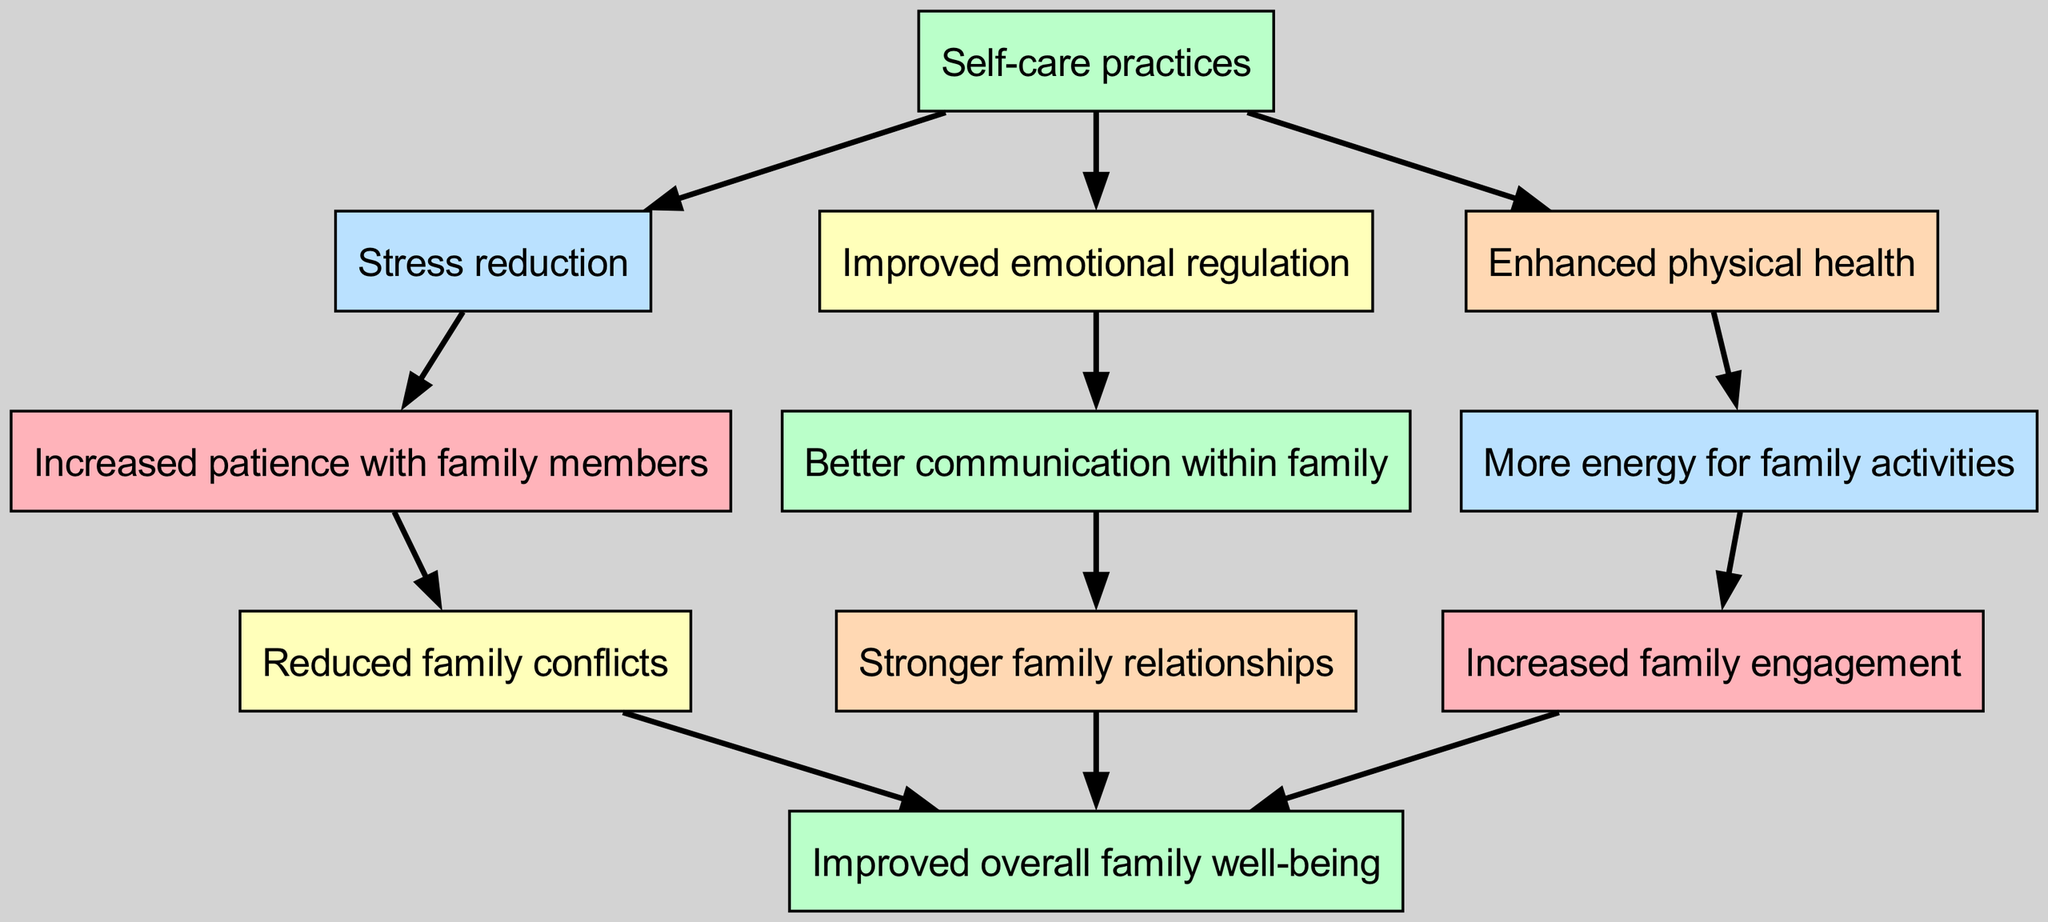What are the first self-care practices mentioned in the diagram? The first self-care practices are listed as nodes under the main element of "Self-care practices". They include "Stress reduction", "Improved emotional regulation", and "Enhanced physical health".
Answer: Stress reduction, Improved emotional regulation, Enhanced physical health How many children does "Stress reduction" have? In the diagram, "Stress reduction" has one child node, which is "Increased patience with family members".
Answer: 1 What is the relationship between "Enhanced physical health" and "Improved overall family well-being"? "Enhanced physical health" leads to "More energy for family activities", which ultimately contributes to "Improved overall family well-being" through increased family engagement.
Answer: Contributes through increased family engagement Which node leads to "Reduced family conflicts"? "Increased patience with family members", a child of "Stress reduction", leads directly to "Reduced family conflicts", indicating that patience can help mitigate conflicts within the family.
Answer: Increased patience with family members How many total nodes are present in the diagram? The total number of nodes in the diagram can be counted directly from the elements listed. There are 11 unique nodes present.
Answer: 11 What is the final outcome of increased family engagement? The final outcome is "Improved overall family well-being", indicating a direct benefit from increased engagement in family activities.
Answer: Improved overall family well-being What links "Better communication within family" to another outcome? "Better communication within family" links to "Stronger family relationships," indicating that improved communication fosters stronger family ties and dynamics.
Answer: Stronger family relationships Which self-care practice results directly in enhanced physical health? "Enhanced physical health" is directly linked as a child of "Self-care practices", showcasing that engaging in self-care contributes to better physical health.
Answer: Enhanced physical health What is the common impact of all self-care practices in the diagram? The common impact of all self-care practices culminates in "Improved overall family well-being", indicating that self-care benefits not only the individual but the family unit as a whole.
Answer: Improved overall family well-being 